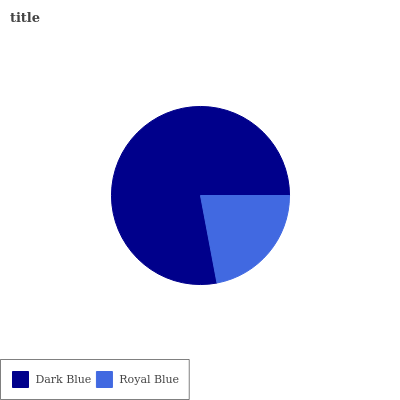Is Royal Blue the minimum?
Answer yes or no. Yes. Is Dark Blue the maximum?
Answer yes or no. Yes. Is Royal Blue the maximum?
Answer yes or no. No. Is Dark Blue greater than Royal Blue?
Answer yes or no. Yes. Is Royal Blue less than Dark Blue?
Answer yes or no. Yes. Is Royal Blue greater than Dark Blue?
Answer yes or no. No. Is Dark Blue less than Royal Blue?
Answer yes or no. No. Is Dark Blue the high median?
Answer yes or no. Yes. Is Royal Blue the low median?
Answer yes or no. Yes. Is Royal Blue the high median?
Answer yes or no. No. Is Dark Blue the low median?
Answer yes or no. No. 